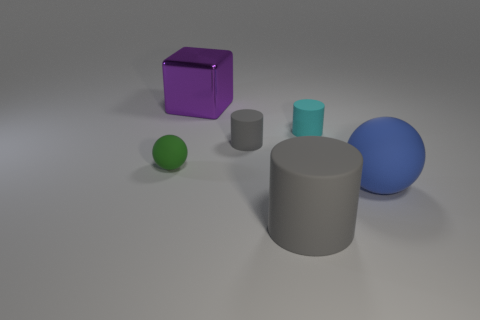What is the size of the cyan thing that is made of the same material as the large blue sphere?
Offer a terse response. Small. Are there more tiny gray rubber cylinders that are in front of the purple cube than tiny brown spheres?
Provide a short and direct response. Yes. What is the gray object behind the large object in front of the large rubber sphere right of the tiny cyan cylinder made of?
Your answer should be very brief. Rubber. Does the cyan cylinder have the same material as the ball that is to the left of the large blue rubber sphere?
Your answer should be very brief. Yes. There is a small gray thing that is the same shape as the big gray thing; what is it made of?
Your answer should be compact. Rubber. Is there any other thing that has the same material as the blue thing?
Your answer should be compact. Yes. Are there more shiny things that are behind the purple object than big matte things right of the blue thing?
Your response must be concise. No. There is a large gray object that is made of the same material as the small sphere; what shape is it?
Give a very brief answer. Cylinder. How many other objects are the same shape as the big blue object?
Your response must be concise. 1. What is the shape of the big object to the right of the small cyan object?
Offer a terse response. Sphere. 